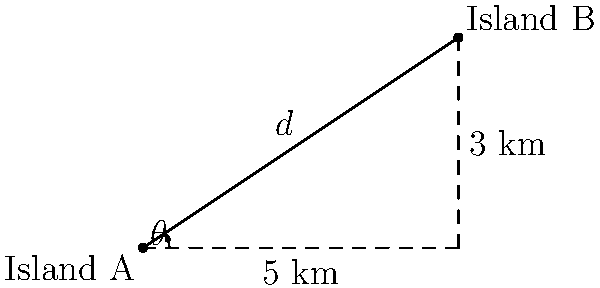From your island (Island A), you can see another island (Island B) in the distance. Using surveying equipment, you determine that Island B is at a bearing of $33.69^\circ$ from your location. You also know that the distance east from your island to a point directly south of Island B is 5 km, and the distance north from that point to Island B is 3 km. What is the direct distance $d$ between Island A and Island B? To solve this problem, we can use the Pythagorean theorem:

1) Let's consider the right triangle formed by the two islands and the point directly south of Island B.

2) We know two sides of this right triangle:
   - The base (east distance) is 5 km
   - The height (north distance) is 3 km

3) We can find the hypotenuse (direct distance $d$) using the Pythagorean theorem:

   $d^2 = 5^2 + 3^2$

4) Simplify:
   $d^2 = 25 + 9 = 34$

5) Take the square root of both sides:
   $d = \sqrt{34}$

6) Simplify:
   $d = \sqrt{34} \approx 5.83$ km

Therefore, the direct distance between Island A and Island B is approximately 5.83 km.

Note: The bearing angle $\theta = 33.69^\circ$ given in the question can be verified using the inverse tangent function:

$\theta = \tan^{-1}(\frac{3}{5}) \approx 33.69^\circ$

This confirms the consistency of the given information.
Answer: $\sqrt{34}$ km or approximately 5.83 km 